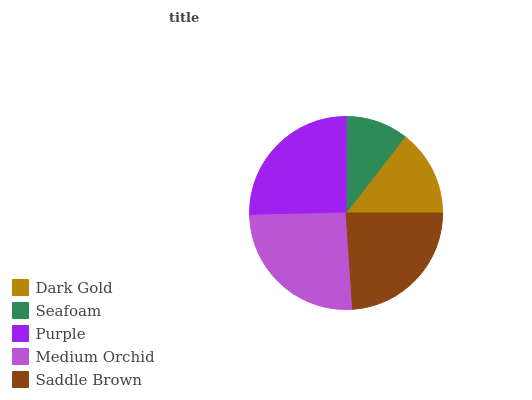Is Seafoam the minimum?
Answer yes or no. Yes. Is Medium Orchid the maximum?
Answer yes or no. Yes. Is Purple the minimum?
Answer yes or no. No. Is Purple the maximum?
Answer yes or no. No. Is Purple greater than Seafoam?
Answer yes or no. Yes. Is Seafoam less than Purple?
Answer yes or no. Yes. Is Seafoam greater than Purple?
Answer yes or no. No. Is Purple less than Seafoam?
Answer yes or no. No. Is Saddle Brown the high median?
Answer yes or no. Yes. Is Saddle Brown the low median?
Answer yes or no. Yes. Is Purple the high median?
Answer yes or no. No. Is Dark Gold the low median?
Answer yes or no. No. 